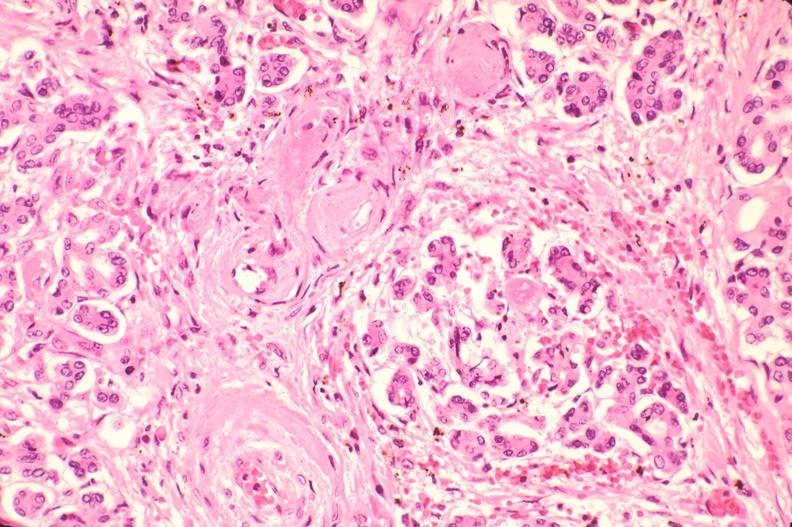s vessel present?
Answer the question using a single word or phrase. No 